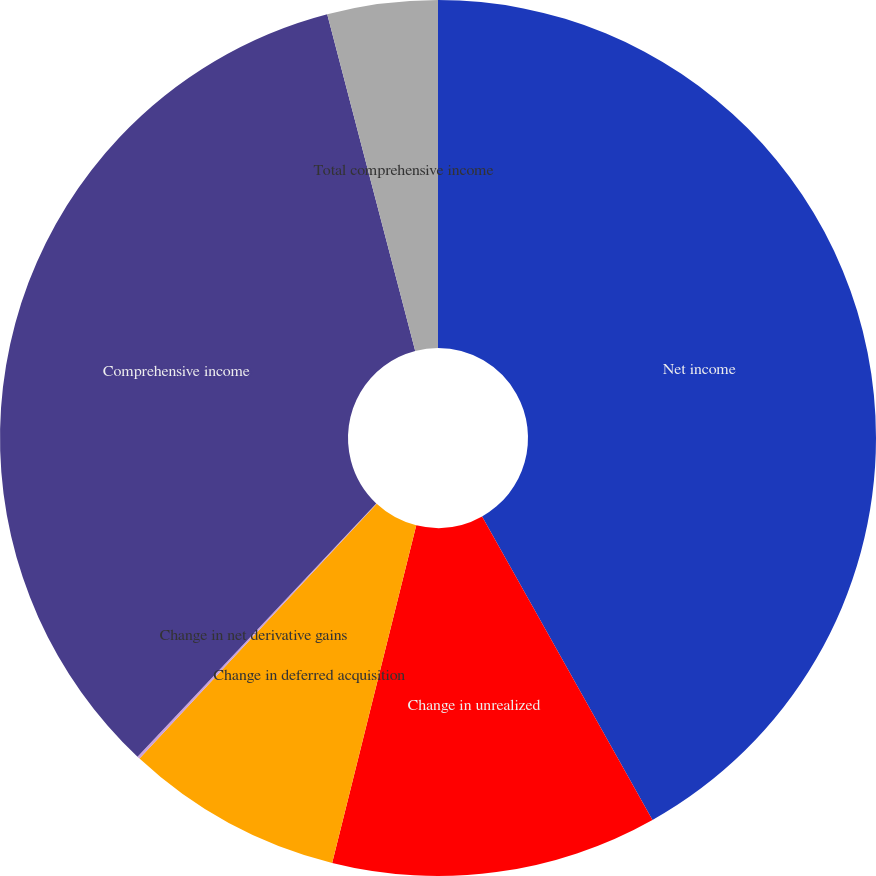<chart> <loc_0><loc_0><loc_500><loc_500><pie_chart><fcel>Net income<fcel>Change in unrealized<fcel>Change in deferred acquisition<fcel>Change in net derivative gains<fcel>Comprehensive income<fcel>Total comprehensive income<nl><fcel>41.86%<fcel>12.03%<fcel>8.05%<fcel>0.1%<fcel>33.9%<fcel>4.07%<nl></chart> 